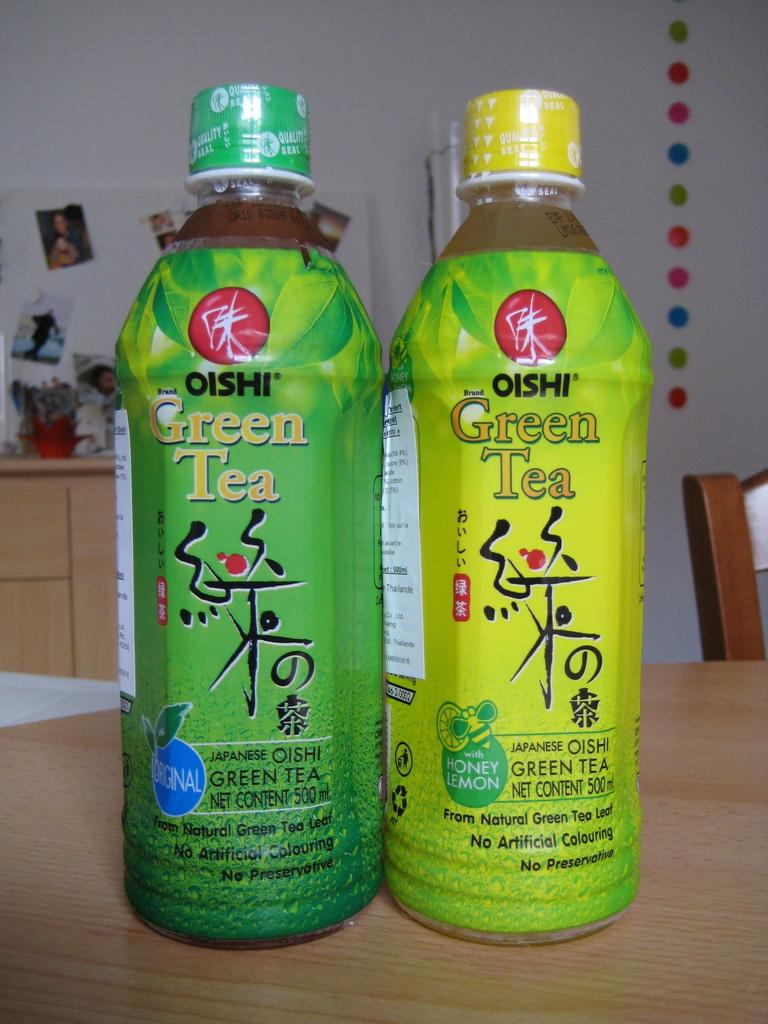<image>
Present a compact description of the photo's key features. Two bottle of Oishi branded Green Tea on a table. 